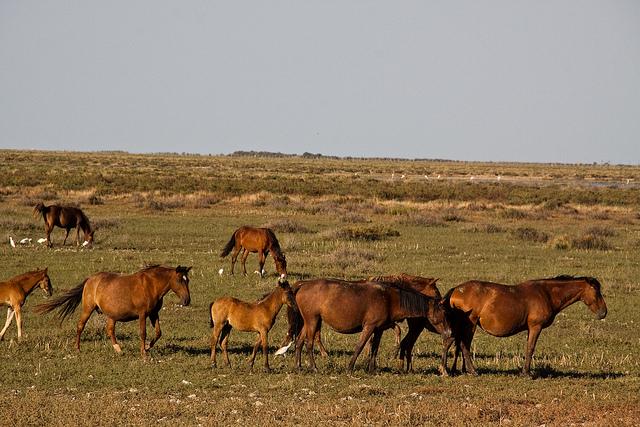Are the horses walking?
Short answer required. Yes. How many horses are in the picture?
Quick response, please. 8. How many horses are there?
Quick response, please. 8. Are all of the horses adult horses?
Quick response, please. No. Can the horses swim?
Quick response, please. Yes. 